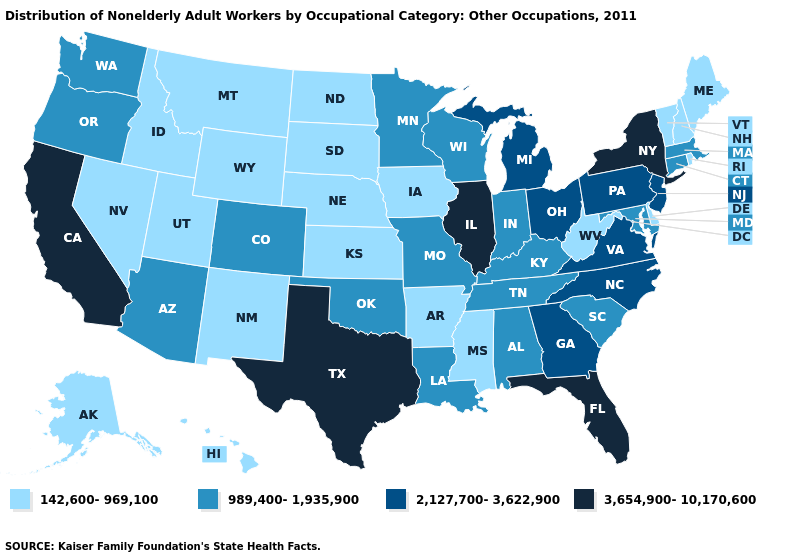Among the states that border Delaware , does Pennsylvania have the highest value?
Give a very brief answer. Yes. What is the lowest value in states that border Rhode Island?
Quick response, please. 989,400-1,935,900. Among the states that border Texas , which have the lowest value?
Write a very short answer. Arkansas, New Mexico. What is the value of Iowa?
Be succinct. 142,600-969,100. What is the lowest value in the South?
Be succinct. 142,600-969,100. What is the value of California?
Write a very short answer. 3,654,900-10,170,600. Name the states that have a value in the range 2,127,700-3,622,900?
Be succinct. Georgia, Michigan, New Jersey, North Carolina, Ohio, Pennsylvania, Virginia. Does New York have the highest value in the USA?
Short answer required. Yes. What is the highest value in the MidWest ?
Write a very short answer. 3,654,900-10,170,600. Name the states that have a value in the range 2,127,700-3,622,900?
Give a very brief answer. Georgia, Michigan, New Jersey, North Carolina, Ohio, Pennsylvania, Virginia. Name the states that have a value in the range 989,400-1,935,900?
Be succinct. Alabama, Arizona, Colorado, Connecticut, Indiana, Kentucky, Louisiana, Maryland, Massachusetts, Minnesota, Missouri, Oklahoma, Oregon, South Carolina, Tennessee, Washington, Wisconsin. Which states have the lowest value in the USA?
Quick response, please. Alaska, Arkansas, Delaware, Hawaii, Idaho, Iowa, Kansas, Maine, Mississippi, Montana, Nebraska, Nevada, New Hampshire, New Mexico, North Dakota, Rhode Island, South Dakota, Utah, Vermont, West Virginia, Wyoming. Name the states that have a value in the range 989,400-1,935,900?
Concise answer only. Alabama, Arizona, Colorado, Connecticut, Indiana, Kentucky, Louisiana, Maryland, Massachusetts, Minnesota, Missouri, Oklahoma, Oregon, South Carolina, Tennessee, Washington, Wisconsin. How many symbols are there in the legend?
Give a very brief answer. 4. 